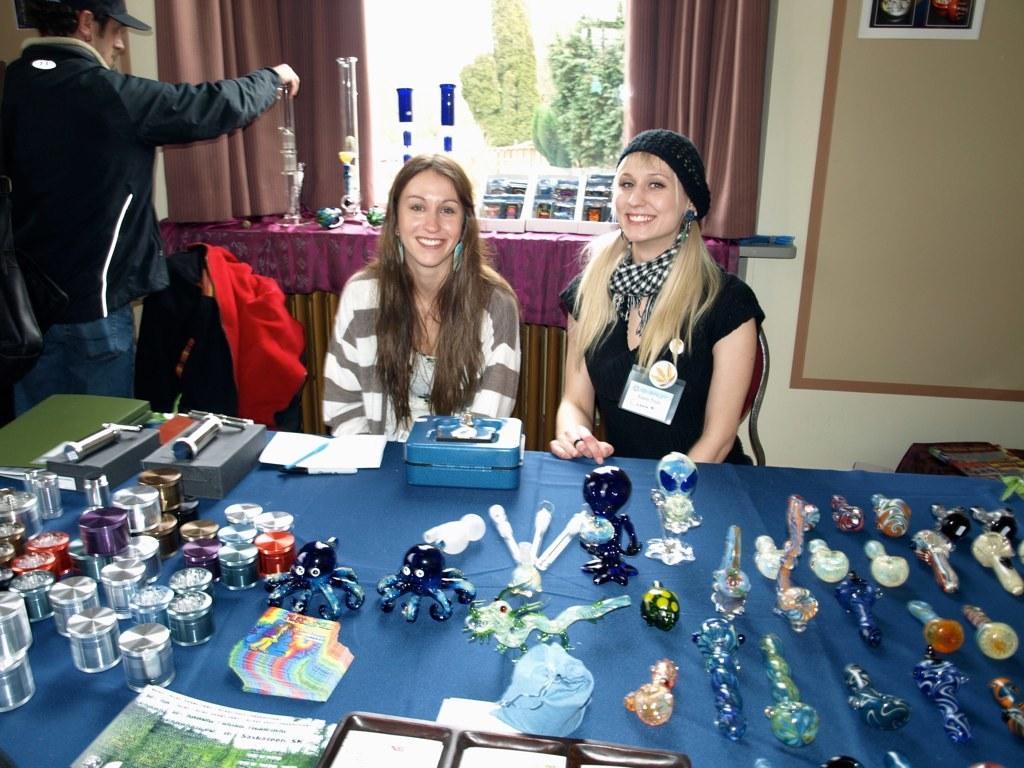How would you summarize this image in a sentence or two? In this picture we can see two women sitting on chairs and smiling and in front of them on the table we can see jars, toys and some objects and in the background we can see a man standing, curtains, trees, poster on the wall. 